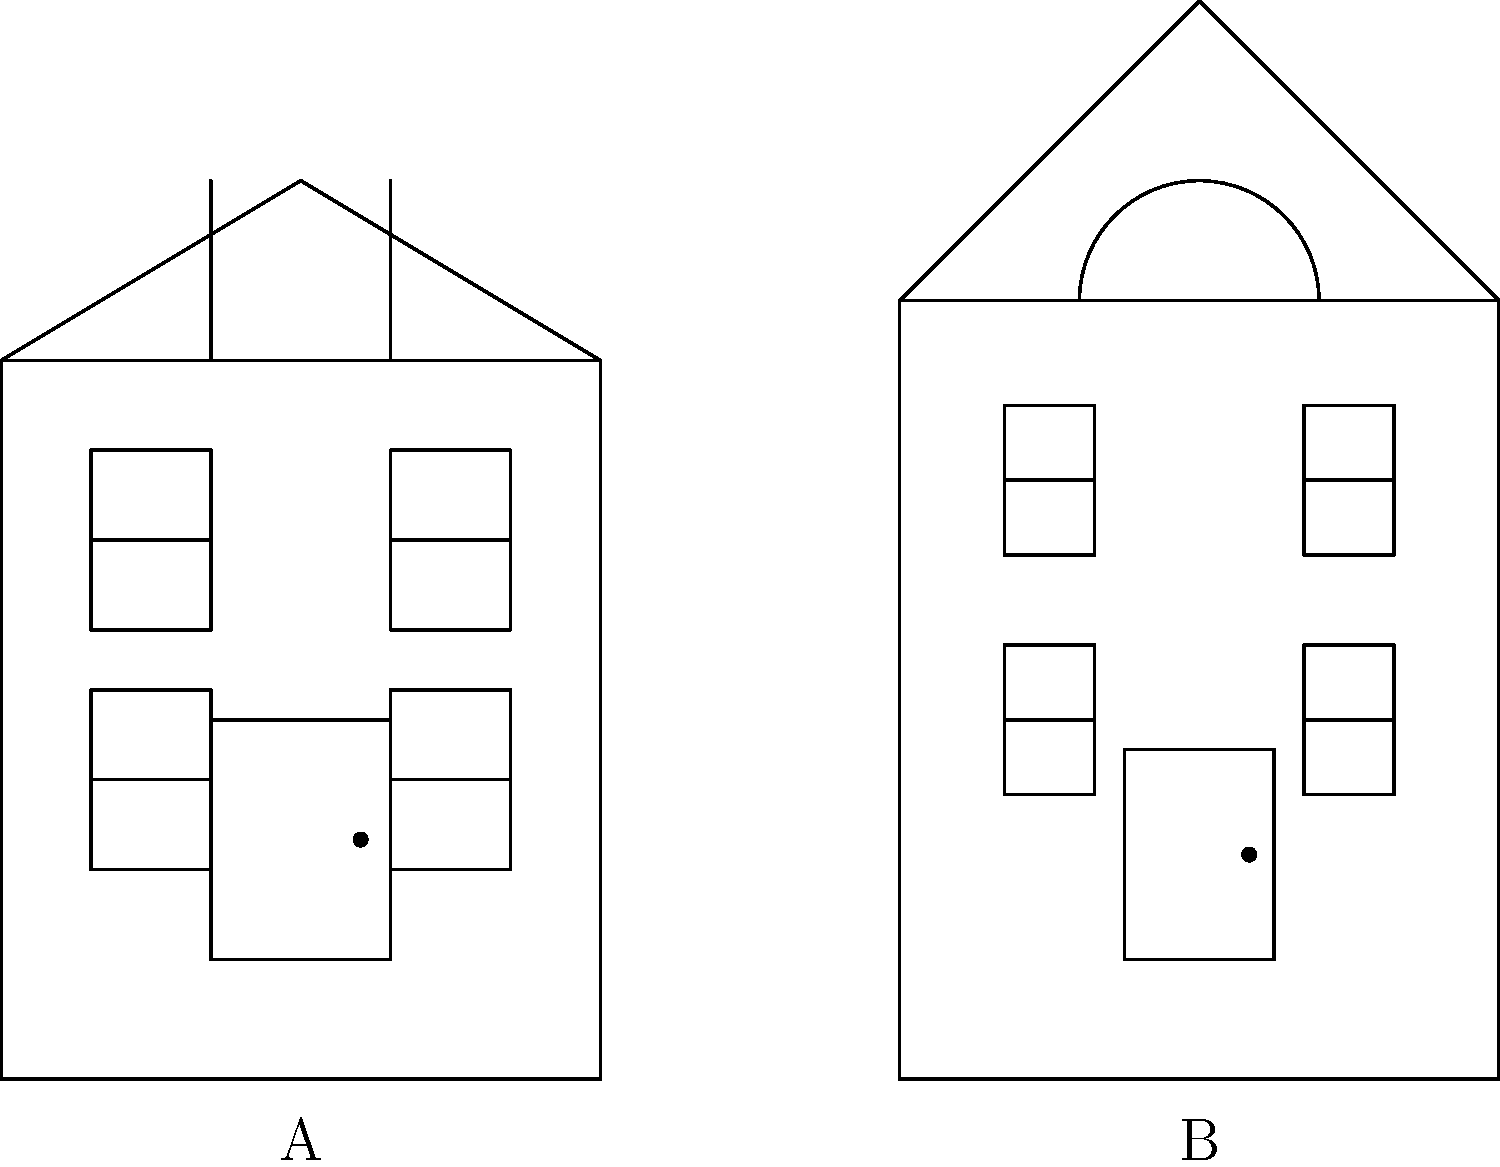Which of the two building facades (A or B) represents the Greek Revival architectural style, commonly found in many historic buildings in Watertown, New York? To determine which facade represents the Greek Revival style, let's analyze the key features of both buildings:

1. Building A:
   - Symmetrical design with a central door
   - Low-pitched triangular roof (pediment)
   - Columns or pilasters flanking the entrance
   - Rectangular windows arranged symmetrically
   - Simple, bold lines and minimal ornamentation

2. Building B:
   - Asymmetrical design
   - Steep, complex roof shape
   - Decorative arched element above the roof
   - Varied window sizes and placements
   - More ornate overall appearance

The Greek Revival style, popular in the United States from the 1820s to 1860s, is characterized by its attempt to emulate the look of ancient Greek temples. Key features include:

- Symmetrical shape
- Low-pitched roof with a triangular pediment
- Columns or pilasters
- Elaborate door surrounds
- Rectangular windows

Based on these characteristics, Building A clearly represents the Greek Revival style. It showcases the symmetrical design, low-pitched triangular roof (pediment), evenly spaced rectangular windows, and a central door typical of Greek Revival architecture.

Building B, on the other hand, displays features more consistent with Victorian architecture, such as asymmetry, steeper roof pitch, and decorative elements like the arched detail above the roofline.
Answer: A 